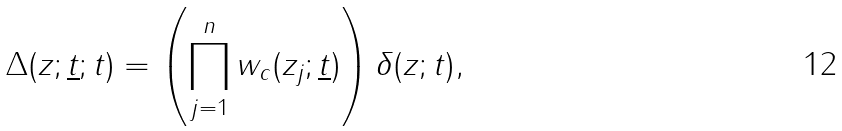Convert formula to latex. <formula><loc_0><loc_0><loc_500><loc_500>\Delta ( z ; \underline { t } ; t ) = \left ( \prod _ { j = 1 } ^ { n } w _ { c } ( z _ { j } ; \underline { t } ) \right ) \delta ( z ; t ) ,</formula> 